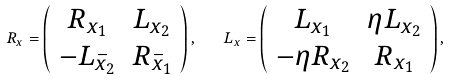<formula> <loc_0><loc_0><loc_500><loc_500>R _ { x } = \left ( \begin{array} { c c } R _ { x _ { 1 } } & L _ { x _ { 2 } } \\ - L _ { \bar { x } _ { 2 } } & R _ { \bar { x } _ { 1 } } \end{array} \right ) , \quad L _ { x } = \left ( \begin{array} { c c } L _ { x _ { 1 } } & \eta L _ { x _ { 2 } } \\ - \eta R _ { x _ { 2 } } & R _ { x _ { 1 } } \end{array} \right ) ,</formula> 